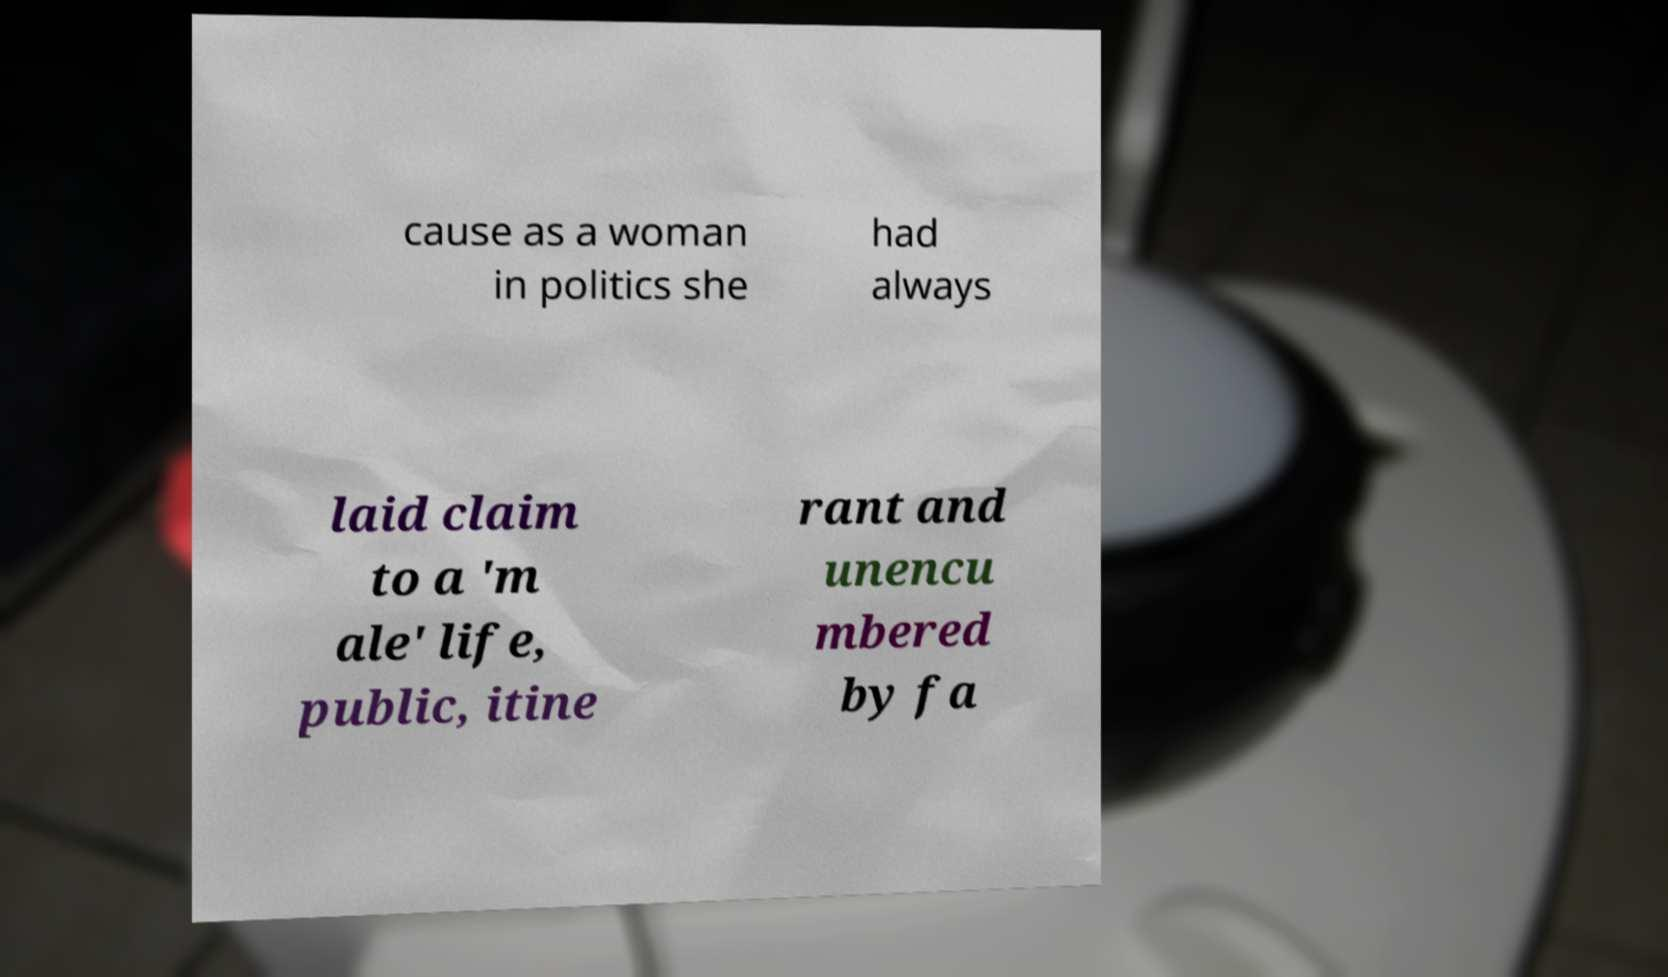Could you extract and type out the text from this image? cause as a woman in politics she had always laid claim to a 'm ale' life, public, itine rant and unencu mbered by fa 